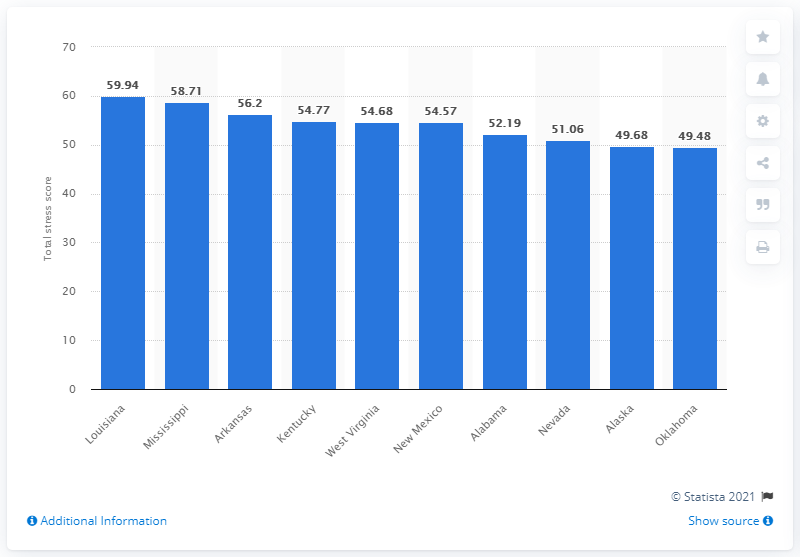Mention a couple of crucial points in this snapshot. According to a recent study, the state of Louisiana was found to be the most stressed state in the United States as of 2019. 